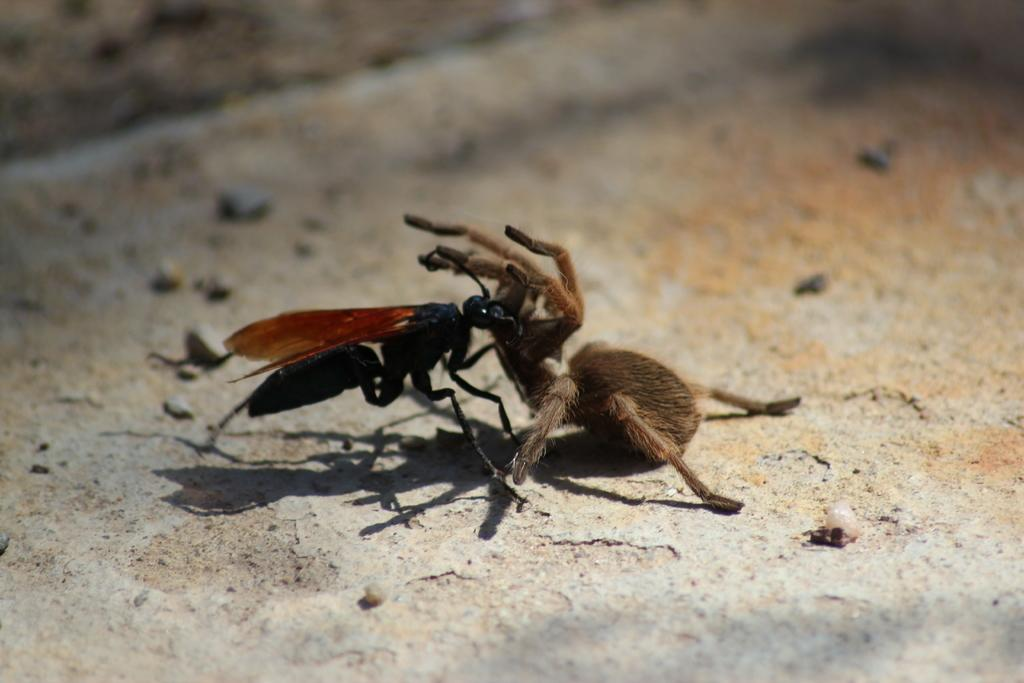What type of insect is present in the image? There is an ant in the image. What other creature can be seen in the image? There is a spider in the image. What is the setting of the image? The background of the image is the ground. What type of plot is being developed by the ant and the spider in the image? There is no plot being developed by the ant and the spider in the image, as they are insects and do not engage in such activities. 